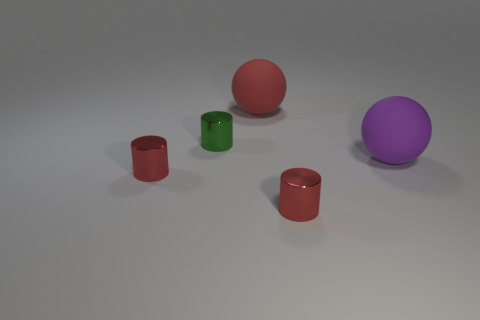Is there a gray metallic cube of the same size as the green shiny cylinder?
Keep it short and to the point. No. What is the size of the matte sphere in front of the small green shiny object?
Ensure brevity in your answer.  Large. Is there a large thing that is to the left of the tiny red cylinder right of the big red rubber thing?
Provide a succinct answer. Yes. What number of other objects are the same shape as the big purple thing?
Your answer should be compact. 1. Does the big red thing have the same shape as the large purple thing?
Offer a very short reply. Yes. What color is the object that is both to the right of the big red matte sphere and left of the purple ball?
Keep it short and to the point. Red. How many small things are either red balls or green things?
Give a very brief answer. 1. There is a small thing that is right of the big rubber sphere behind the rubber object that is in front of the large red rubber object; what is its material?
Your answer should be compact. Metal. What number of rubber things are either small cylinders or big purple balls?
Keep it short and to the point. 1. How many gray objects are big objects or cylinders?
Your answer should be very brief. 0. 